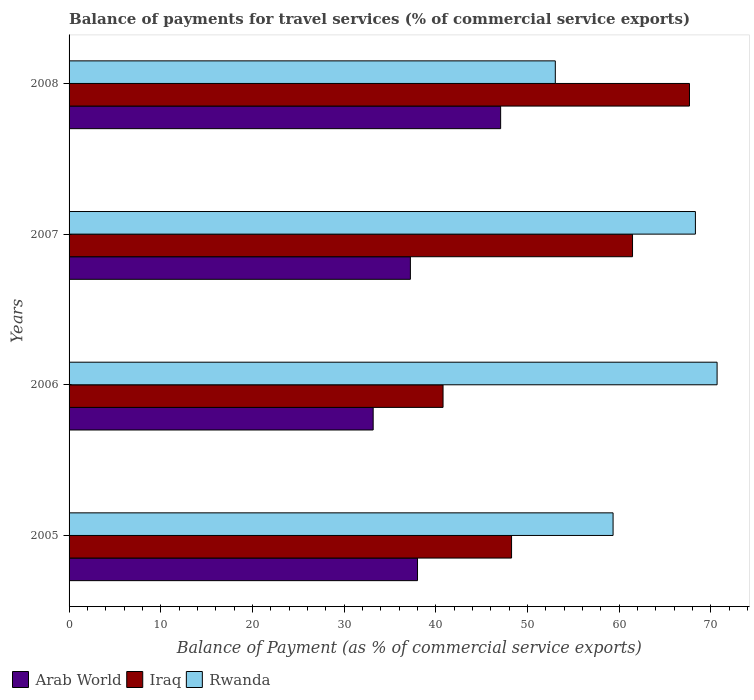How many different coloured bars are there?
Keep it short and to the point. 3. How many bars are there on the 3rd tick from the top?
Your response must be concise. 3. How many bars are there on the 4th tick from the bottom?
Offer a very short reply. 3. What is the balance of payments for travel services in Iraq in 2007?
Your response must be concise. 61.45. Across all years, what is the maximum balance of payments for travel services in Rwanda?
Make the answer very short. 70.67. Across all years, what is the minimum balance of payments for travel services in Arab World?
Your answer should be compact. 33.17. In which year was the balance of payments for travel services in Arab World maximum?
Provide a succinct answer. 2008. In which year was the balance of payments for travel services in Arab World minimum?
Your response must be concise. 2006. What is the total balance of payments for travel services in Arab World in the graph?
Provide a short and direct response. 155.46. What is the difference between the balance of payments for travel services in Arab World in 2007 and that in 2008?
Offer a terse response. -9.84. What is the difference between the balance of payments for travel services in Iraq in 2006 and the balance of payments for travel services in Rwanda in 2005?
Ensure brevity in your answer.  -18.54. What is the average balance of payments for travel services in Iraq per year?
Offer a terse response. 54.54. In the year 2006, what is the difference between the balance of payments for travel services in Rwanda and balance of payments for travel services in Arab World?
Your answer should be very brief. 37.51. What is the ratio of the balance of payments for travel services in Arab World in 2005 to that in 2006?
Your answer should be very brief. 1.15. Is the balance of payments for travel services in Rwanda in 2005 less than that in 2008?
Give a very brief answer. No. What is the difference between the highest and the second highest balance of payments for travel services in Rwanda?
Your answer should be compact. 2.36. What is the difference between the highest and the lowest balance of payments for travel services in Rwanda?
Offer a terse response. 17.64. In how many years, is the balance of payments for travel services in Iraq greater than the average balance of payments for travel services in Iraq taken over all years?
Make the answer very short. 2. Is the sum of the balance of payments for travel services in Rwanda in 2006 and 2007 greater than the maximum balance of payments for travel services in Arab World across all years?
Offer a terse response. Yes. What does the 2nd bar from the top in 2006 represents?
Provide a succinct answer. Iraq. What does the 3rd bar from the bottom in 2007 represents?
Your response must be concise. Rwanda. Is it the case that in every year, the sum of the balance of payments for travel services in Rwanda and balance of payments for travel services in Arab World is greater than the balance of payments for travel services in Iraq?
Your response must be concise. Yes. How many bars are there?
Provide a short and direct response. 12. Are all the bars in the graph horizontal?
Offer a very short reply. Yes. How many years are there in the graph?
Offer a very short reply. 4. Are the values on the major ticks of X-axis written in scientific E-notation?
Your answer should be very brief. No. What is the title of the graph?
Give a very brief answer. Balance of payments for travel services (% of commercial service exports). What is the label or title of the X-axis?
Your answer should be compact. Balance of Payment (as % of commercial service exports). What is the Balance of Payment (as % of commercial service exports) in Arab World in 2005?
Ensure brevity in your answer.  38. What is the Balance of Payment (as % of commercial service exports) in Iraq in 2005?
Provide a succinct answer. 48.26. What is the Balance of Payment (as % of commercial service exports) in Rwanda in 2005?
Your answer should be very brief. 59.33. What is the Balance of Payment (as % of commercial service exports) in Arab World in 2006?
Offer a terse response. 33.17. What is the Balance of Payment (as % of commercial service exports) in Iraq in 2006?
Your answer should be very brief. 40.79. What is the Balance of Payment (as % of commercial service exports) of Rwanda in 2006?
Your response must be concise. 70.67. What is the Balance of Payment (as % of commercial service exports) in Arab World in 2007?
Offer a very short reply. 37.22. What is the Balance of Payment (as % of commercial service exports) of Iraq in 2007?
Offer a very short reply. 61.45. What is the Balance of Payment (as % of commercial service exports) in Rwanda in 2007?
Provide a succinct answer. 68.31. What is the Balance of Payment (as % of commercial service exports) of Arab World in 2008?
Keep it short and to the point. 47.07. What is the Balance of Payment (as % of commercial service exports) of Iraq in 2008?
Give a very brief answer. 67.66. What is the Balance of Payment (as % of commercial service exports) of Rwanda in 2008?
Your answer should be very brief. 53.03. Across all years, what is the maximum Balance of Payment (as % of commercial service exports) in Arab World?
Your answer should be very brief. 47.07. Across all years, what is the maximum Balance of Payment (as % of commercial service exports) of Iraq?
Keep it short and to the point. 67.66. Across all years, what is the maximum Balance of Payment (as % of commercial service exports) in Rwanda?
Give a very brief answer. 70.67. Across all years, what is the minimum Balance of Payment (as % of commercial service exports) in Arab World?
Ensure brevity in your answer.  33.17. Across all years, what is the minimum Balance of Payment (as % of commercial service exports) in Iraq?
Make the answer very short. 40.79. Across all years, what is the minimum Balance of Payment (as % of commercial service exports) of Rwanda?
Keep it short and to the point. 53.03. What is the total Balance of Payment (as % of commercial service exports) of Arab World in the graph?
Offer a terse response. 155.46. What is the total Balance of Payment (as % of commercial service exports) of Iraq in the graph?
Provide a succinct answer. 218.16. What is the total Balance of Payment (as % of commercial service exports) of Rwanda in the graph?
Your answer should be compact. 251.34. What is the difference between the Balance of Payment (as % of commercial service exports) of Arab World in 2005 and that in 2006?
Offer a terse response. 4.84. What is the difference between the Balance of Payment (as % of commercial service exports) of Iraq in 2005 and that in 2006?
Give a very brief answer. 7.47. What is the difference between the Balance of Payment (as % of commercial service exports) in Rwanda in 2005 and that in 2006?
Keep it short and to the point. -11.34. What is the difference between the Balance of Payment (as % of commercial service exports) in Arab World in 2005 and that in 2007?
Provide a short and direct response. 0.78. What is the difference between the Balance of Payment (as % of commercial service exports) in Iraq in 2005 and that in 2007?
Make the answer very short. -13.19. What is the difference between the Balance of Payment (as % of commercial service exports) of Rwanda in 2005 and that in 2007?
Offer a terse response. -8.98. What is the difference between the Balance of Payment (as % of commercial service exports) of Arab World in 2005 and that in 2008?
Your answer should be very brief. -9.07. What is the difference between the Balance of Payment (as % of commercial service exports) of Iraq in 2005 and that in 2008?
Provide a short and direct response. -19.4. What is the difference between the Balance of Payment (as % of commercial service exports) of Rwanda in 2005 and that in 2008?
Give a very brief answer. 6.3. What is the difference between the Balance of Payment (as % of commercial service exports) in Arab World in 2006 and that in 2007?
Your answer should be very brief. -4.06. What is the difference between the Balance of Payment (as % of commercial service exports) in Iraq in 2006 and that in 2007?
Give a very brief answer. -20.66. What is the difference between the Balance of Payment (as % of commercial service exports) of Rwanda in 2006 and that in 2007?
Your answer should be compact. 2.37. What is the difference between the Balance of Payment (as % of commercial service exports) of Arab World in 2006 and that in 2008?
Provide a short and direct response. -13.9. What is the difference between the Balance of Payment (as % of commercial service exports) of Iraq in 2006 and that in 2008?
Keep it short and to the point. -26.88. What is the difference between the Balance of Payment (as % of commercial service exports) of Rwanda in 2006 and that in 2008?
Offer a terse response. 17.64. What is the difference between the Balance of Payment (as % of commercial service exports) in Arab World in 2007 and that in 2008?
Provide a succinct answer. -9.84. What is the difference between the Balance of Payment (as % of commercial service exports) of Iraq in 2007 and that in 2008?
Your answer should be very brief. -6.21. What is the difference between the Balance of Payment (as % of commercial service exports) of Rwanda in 2007 and that in 2008?
Provide a succinct answer. 15.28. What is the difference between the Balance of Payment (as % of commercial service exports) of Arab World in 2005 and the Balance of Payment (as % of commercial service exports) of Iraq in 2006?
Provide a succinct answer. -2.79. What is the difference between the Balance of Payment (as % of commercial service exports) of Arab World in 2005 and the Balance of Payment (as % of commercial service exports) of Rwanda in 2006?
Your answer should be very brief. -32.67. What is the difference between the Balance of Payment (as % of commercial service exports) of Iraq in 2005 and the Balance of Payment (as % of commercial service exports) of Rwanda in 2006?
Provide a succinct answer. -22.41. What is the difference between the Balance of Payment (as % of commercial service exports) in Arab World in 2005 and the Balance of Payment (as % of commercial service exports) in Iraq in 2007?
Your answer should be compact. -23.45. What is the difference between the Balance of Payment (as % of commercial service exports) of Arab World in 2005 and the Balance of Payment (as % of commercial service exports) of Rwanda in 2007?
Provide a short and direct response. -30.31. What is the difference between the Balance of Payment (as % of commercial service exports) of Iraq in 2005 and the Balance of Payment (as % of commercial service exports) of Rwanda in 2007?
Keep it short and to the point. -20.05. What is the difference between the Balance of Payment (as % of commercial service exports) of Arab World in 2005 and the Balance of Payment (as % of commercial service exports) of Iraq in 2008?
Your answer should be very brief. -29.66. What is the difference between the Balance of Payment (as % of commercial service exports) of Arab World in 2005 and the Balance of Payment (as % of commercial service exports) of Rwanda in 2008?
Your answer should be very brief. -15.03. What is the difference between the Balance of Payment (as % of commercial service exports) of Iraq in 2005 and the Balance of Payment (as % of commercial service exports) of Rwanda in 2008?
Offer a terse response. -4.77. What is the difference between the Balance of Payment (as % of commercial service exports) of Arab World in 2006 and the Balance of Payment (as % of commercial service exports) of Iraq in 2007?
Your answer should be very brief. -28.29. What is the difference between the Balance of Payment (as % of commercial service exports) of Arab World in 2006 and the Balance of Payment (as % of commercial service exports) of Rwanda in 2007?
Ensure brevity in your answer.  -35.14. What is the difference between the Balance of Payment (as % of commercial service exports) of Iraq in 2006 and the Balance of Payment (as % of commercial service exports) of Rwanda in 2007?
Your answer should be very brief. -27.52. What is the difference between the Balance of Payment (as % of commercial service exports) of Arab World in 2006 and the Balance of Payment (as % of commercial service exports) of Iraq in 2008?
Your response must be concise. -34.5. What is the difference between the Balance of Payment (as % of commercial service exports) in Arab World in 2006 and the Balance of Payment (as % of commercial service exports) in Rwanda in 2008?
Your answer should be compact. -19.86. What is the difference between the Balance of Payment (as % of commercial service exports) in Iraq in 2006 and the Balance of Payment (as % of commercial service exports) in Rwanda in 2008?
Provide a short and direct response. -12.24. What is the difference between the Balance of Payment (as % of commercial service exports) of Arab World in 2007 and the Balance of Payment (as % of commercial service exports) of Iraq in 2008?
Ensure brevity in your answer.  -30.44. What is the difference between the Balance of Payment (as % of commercial service exports) in Arab World in 2007 and the Balance of Payment (as % of commercial service exports) in Rwanda in 2008?
Your answer should be compact. -15.81. What is the difference between the Balance of Payment (as % of commercial service exports) in Iraq in 2007 and the Balance of Payment (as % of commercial service exports) in Rwanda in 2008?
Keep it short and to the point. 8.42. What is the average Balance of Payment (as % of commercial service exports) of Arab World per year?
Give a very brief answer. 38.86. What is the average Balance of Payment (as % of commercial service exports) in Iraq per year?
Your response must be concise. 54.54. What is the average Balance of Payment (as % of commercial service exports) in Rwanda per year?
Offer a terse response. 62.84. In the year 2005, what is the difference between the Balance of Payment (as % of commercial service exports) of Arab World and Balance of Payment (as % of commercial service exports) of Iraq?
Provide a short and direct response. -10.26. In the year 2005, what is the difference between the Balance of Payment (as % of commercial service exports) in Arab World and Balance of Payment (as % of commercial service exports) in Rwanda?
Provide a short and direct response. -21.33. In the year 2005, what is the difference between the Balance of Payment (as % of commercial service exports) in Iraq and Balance of Payment (as % of commercial service exports) in Rwanda?
Give a very brief answer. -11.07. In the year 2006, what is the difference between the Balance of Payment (as % of commercial service exports) of Arab World and Balance of Payment (as % of commercial service exports) of Iraq?
Make the answer very short. -7.62. In the year 2006, what is the difference between the Balance of Payment (as % of commercial service exports) of Arab World and Balance of Payment (as % of commercial service exports) of Rwanda?
Offer a very short reply. -37.51. In the year 2006, what is the difference between the Balance of Payment (as % of commercial service exports) of Iraq and Balance of Payment (as % of commercial service exports) of Rwanda?
Give a very brief answer. -29.89. In the year 2007, what is the difference between the Balance of Payment (as % of commercial service exports) in Arab World and Balance of Payment (as % of commercial service exports) in Iraq?
Provide a succinct answer. -24.23. In the year 2007, what is the difference between the Balance of Payment (as % of commercial service exports) in Arab World and Balance of Payment (as % of commercial service exports) in Rwanda?
Offer a terse response. -31.08. In the year 2007, what is the difference between the Balance of Payment (as % of commercial service exports) in Iraq and Balance of Payment (as % of commercial service exports) in Rwanda?
Offer a terse response. -6.86. In the year 2008, what is the difference between the Balance of Payment (as % of commercial service exports) of Arab World and Balance of Payment (as % of commercial service exports) of Iraq?
Ensure brevity in your answer.  -20.59. In the year 2008, what is the difference between the Balance of Payment (as % of commercial service exports) in Arab World and Balance of Payment (as % of commercial service exports) in Rwanda?
Provide a succinct answer. -5.96. In the year 2008, what is the difference between the Balance of Payment (as % of commercial service exports) in Iraq and Balance of Payment (as % of commercial service exports) in Rwanda?
Offer a very short reply. 14.63. What is the ratio of the Balance of Payment (as % of commercial service exports) in Arab World in 2005 to that in 2006?
Your response must be concise. 1.15. What is the ratio of the Balance of Payment (as % of commercial service exports) of Iraq in 2005 to that in 2006?
Provide a short and direct response. 1.18. What is the ratio of the Balance of Payment (as % of commercial service exports) in Rwanda in 2005 to that in 2006?
Offer a very short reply. 0.84. What is the ratio of the Balance of Payment (as % of commercial service exports) in Arab World in 2005 to that in 2007?
Keep it short and to the point. 1.02. What is the ratio of the Balance of Payment (as % of commercial service exports) of Iraq in 2005 to that in 2007?
Your answer should be compact. 0.79. What is the ratio of the Balance of Payment (as % of commercial service exports) in Rwanda in 2005 to that in 2007?
Give a very brief answer. 0.87. What is the ratio of the Balance of Payment (as % of commercial service exports) of Arab World in 2005 to that in 2008?
Make the answer very short. 0.81. What is the ratio of the Balance of Payment (as % of commercial service exports) of Iraq in 2005 to that in 2008?
Your answer should be very brief. 0.71. What is the ratio of the Balance of Payment (as % of commercial service exports) of Rwanda in 2005 to that in 2008?
Offer a very short reply. 1.12. What is the ratio of the Balance of Payment (as % of commercial service exports) in Arab World in 2006 to that in 2007?
Your answer should be very brief. 0.89. What is the ratio of the Balance of Payment (as % of commercial service exports) of Iraq in 2006 to that in 2007?
Give a very brief answer. 0.66. What is the ratio of the Balance of Payment (as % of commercial service exports) of Rwanda in 2006 to that in 2007?
Provide a succinct answer. 1.03. What is the ratio of the Balance of Payment (as % of commercial service exports) in Arab World in 2006 to that in 2008?
Give a very brief answer. 0.7. What is the ratio of the Balance of Payment (as % of commercial service exports) of Iraq in 2006 to that in 2008?
Provide a succinct answer. 0.6. What is the ratio of the Balance of Payment (as % of commercial service exports) of Rwanda in 2006 to that in 2008?
Your answer should be compact. 1.33. What is the ratio of the Balance of Payment (as % of commercial service exports) in Arab World in 2007 to that in 2008?
Ensure brevity in your answer.  0.79. What is the ratio of the Balance of Payment (as % of commercial service exports) of Iraq in 2007 to that in 2008?
Make the answer very short. 0.91. What is the ratio of the Balance of Payment (as % of commercial service exports) in Rwanda in 2007 to that in 2008?
Keep it short and to the point. 1.29. What is the difference between the highest and the second highest Balance of Payment (as % of commercial service exports) in Arab World?
Give a very brief answer. 9.07. What is the difference between the highest and the second highest Balance of Payment (as % of commercial service exports) of Iraq?
Your response must be concise. 6.21. What is the difference between the highest and the second highest Balance of Payment (as % of commercial service exports) of Rwanda?
Your answer should be very brief. 2.37. What is the difference between the highest and the lowest Balance of Payment (as % of commercial service exports) of Arab World?
Make the answer very short. 13.9. What is the difference between the highest and the lowest Balance of Payment (as % of commercial service exports) of Iraq?
Make the answer very short. 26.88. What is the difference between the highest and the lowest Balance of Payment (as % of commercial service exports) of Rwanda?
Keep it short and to the point. 17.64. 